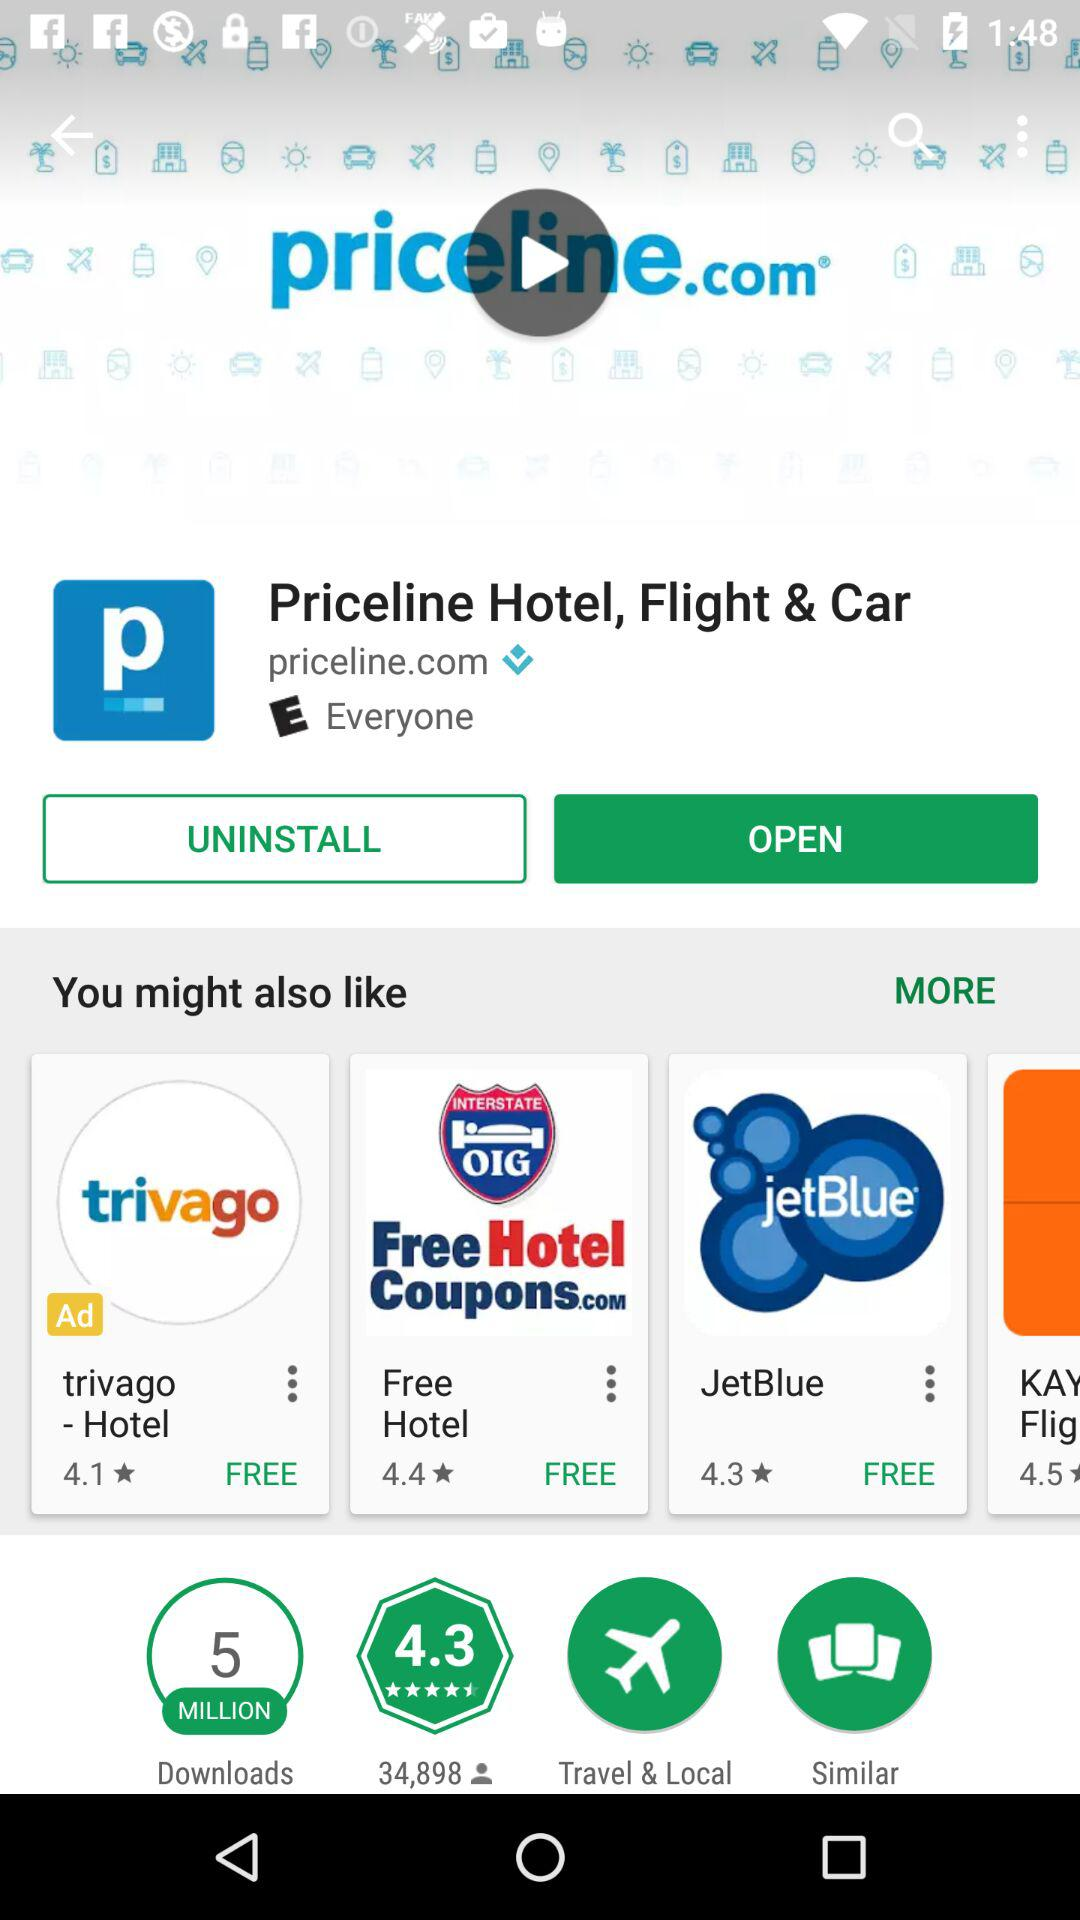What is the duration of the "priceline.com" video?
When the provided information is insufficient, respond with <no answer>. <no answer> 